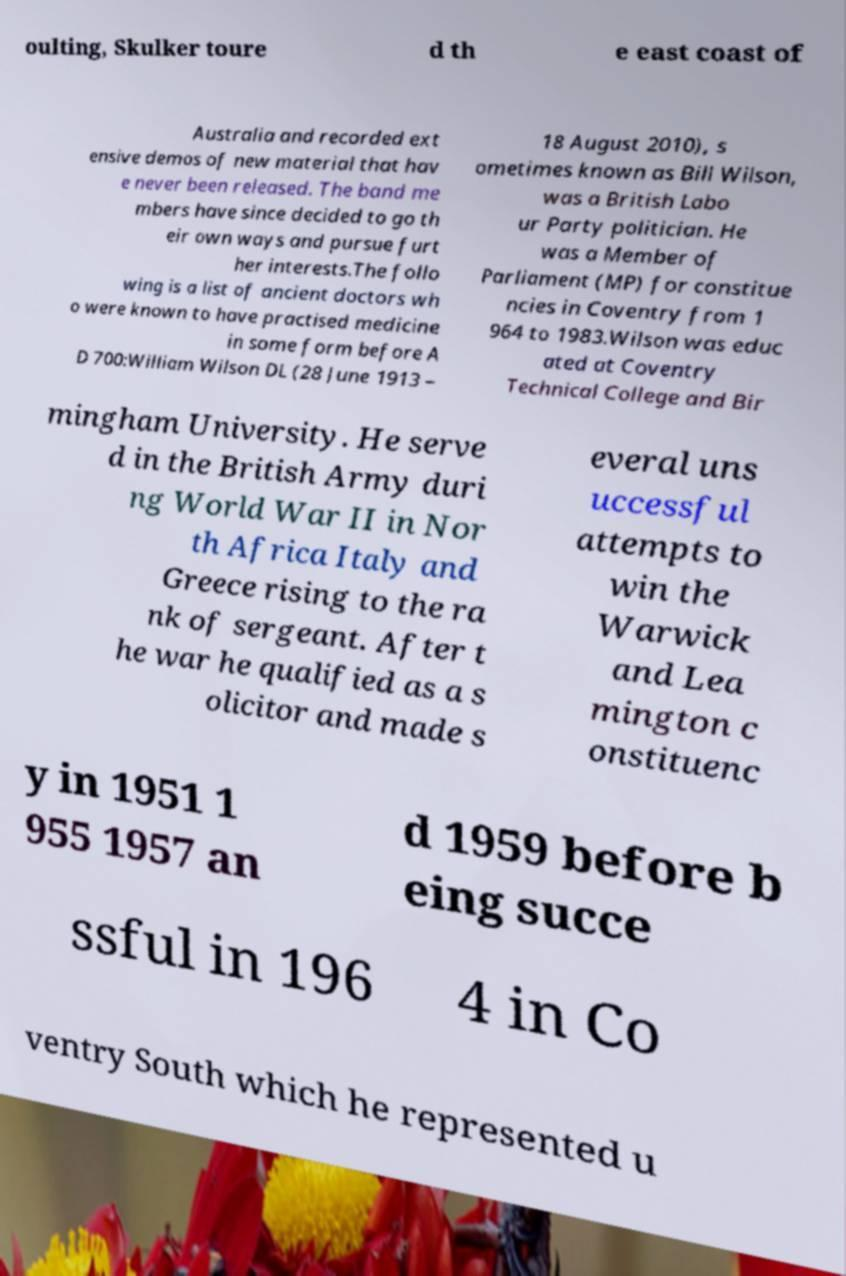Can you accurately transcribe the text from the provided image for me? oulting, Skulker toure d th e east coast of Australia and recorded ext ensive demos of new material that hav e never been released. The band me mbers have since decided to go th eir own ways and pursue furt her interests.The follo wing is a list of ancient doctors wh o were known to have practised medicine in some form before A D 700:William Wilson DL (28 June 1913 – 18 August 2010), s ometimes known as Bill Wilson, was a British Labo ur Party politician. He was a Member of Parliament (MP) for constitue ncies in Coventry from 1 964 to 1983.Wilson was educ ated at Coventry Technical College and Bir mingham University. He serve d in the British Army duri ng World War II in Nor th Africa Italy and Greece rising to the ra nk of sergeant. After t he war he qualified as a s olicitor and made s everal uns uccessful attempts to win the Warwick and Lea mington c onstituenc y in 1951 1 955 1957 an d 1959 before b eing succe ssful in 196 4 in Co ventry South which he represented u 